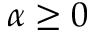<formula> <loc_0><loc_0><loc_500><loc_500>\alpha \geq 0</formula> 